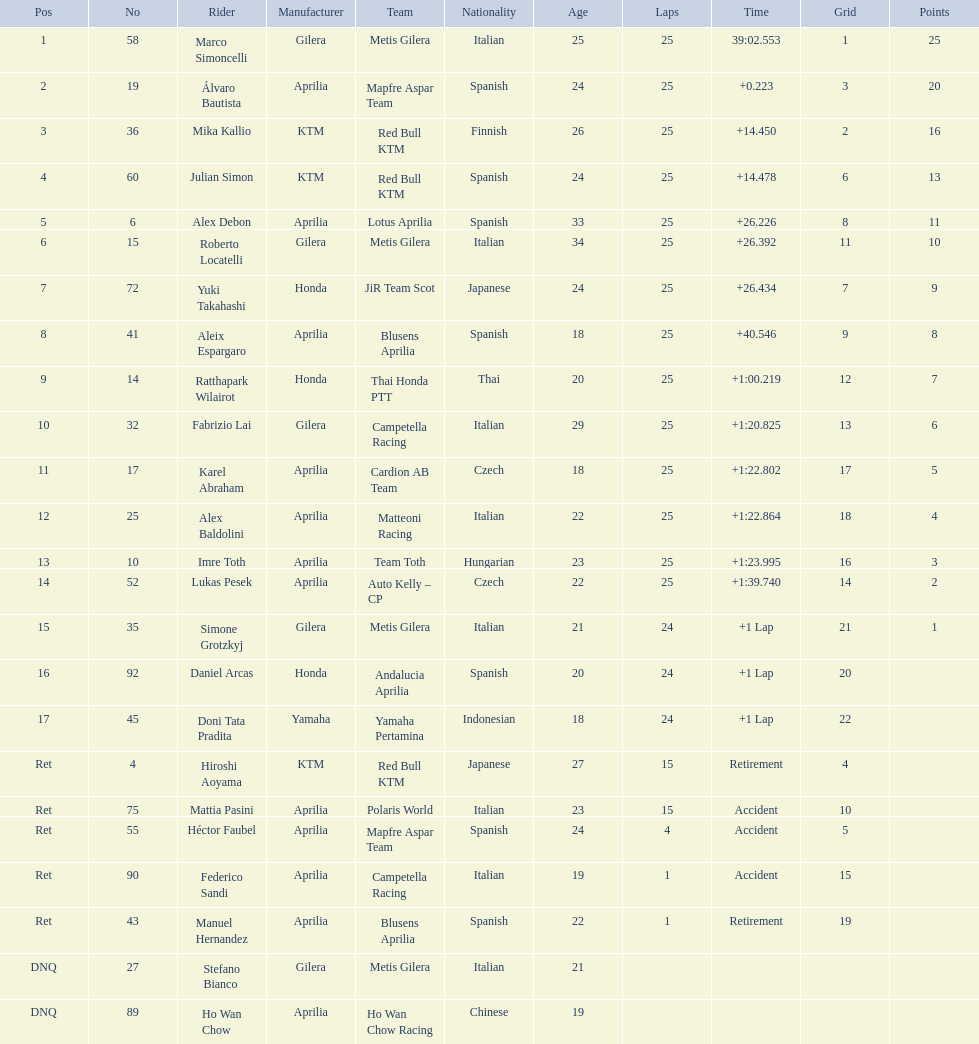How many laps in total has imre toth executed? 25. 